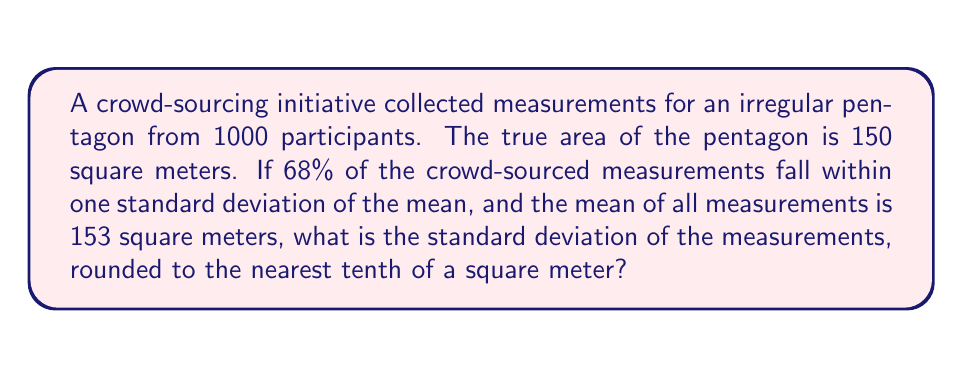Could you help me with this problem? To solve this problem, we'll use the properties of normal distribution and the given information:

1) We know that 68% of the data falls within one standard deviation of the mean in a normal distribution.

2) The mean of the measurements is 153 square meters.

3) The true area is 150 square meters.

Let's denote the standard deviation as $\sigma$.

4) We can set up an equation based on the normal distribution property:

   $153 - \sigma \leq x \leq 153 + \sigma$ for 68% of the measurements

5) Since the true value (150) should be within this range for a reasonably accurate crowd-sourcing result, we can write:

   $153 - \sigma \leq 150 \leq 153 + \sigma$

6) From the right inequality:
   $150 \leq 153 + \sigma$
   $-3 \leq \sigma$

7) From the left inequality:
   $153 - \sigma \leq 150$
   $3 \leq \sigma$

8) Combining these, we get:
   $3 \leq \sigma \leq 3$

9) Therefore, $\sigma = 3$

10) Rounding to the nearest tenth: 3.0 square meters

This result suggests that the crowd-sourced measurements have a standard deviation of 3.0 square meters, indicating the level of variability in the collected data.
Answer: 3.0 square meters 